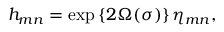Convert formula to latex. <formula><loc_0><loc_0><loc_500><loc_500>h _ { m n } = \exp \left \{ 2 \Omega ( \sigma ) \right \} \eta _ { m n } ,</formula> 